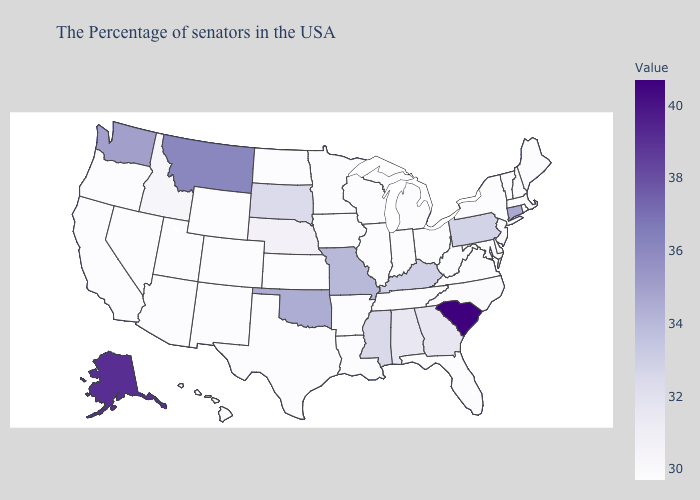Among the states that border Oklahoma , does Colorado have the lowest value?
Short answer required. Yes. Is the legend a continuous bar?
Write a very short answer. Yes. Does Colorado have a lower value than Montana?
Give a very brief answer. Yes. Among the states that border Indiana , does Kentucky have the lowest value?
Keep it brief. No. Does Pennsylvania have the lowest value in the USA?
Short answer required. No. Among the states that border Florida , which have the highest value?
Keep it brief. Georgia. Is the legend a continuous bar?
Concise answer only. Yes. Which states hav the highest value in the Northeast?
Keep it brief. Connecticut. 